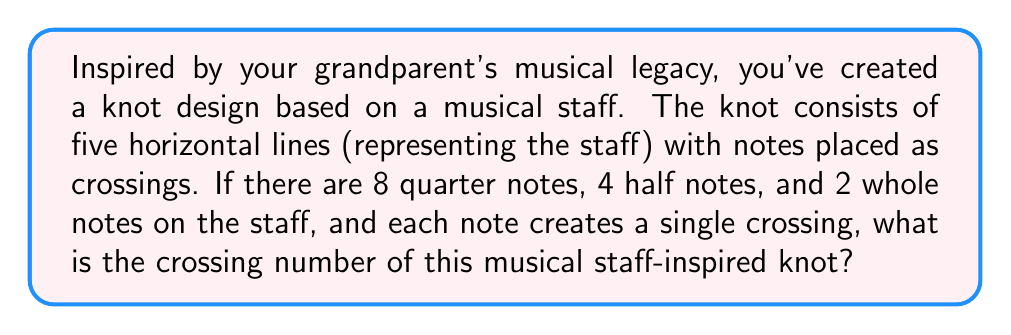What is the answer to this math problem? To calculate the crossing number of this musical staff-inspired knot, we need to follow these steps:

1. Understand the concept of crossing number:
   The crossing number of a knot is the minimum number of crossings that occur in any projection of the knot onto a plane.

2. Count the crossings created by each type of note:
   - Quarter notes: 8 crossings (1 crossing each)
   - Half notes: 4 crossings (1 crossing each)
   - Whole notes: 2 crossings (1 crossing each)

3. Sum up all the crossings:
   Total crossings = Quarter note crossings + Half note crossings + Whole note crossings
   $$\text{Total crossings} = 8 + 4 + 2 = 14$$

4. Consider potential simplifications:
   In this case, since each note creates a single crossing and there are no additional crossings mentioned, the total number of crossings is likely the minimum possible for this knot configuration.

Therefore, the crossing number of this musical staff-inspired knot is 14.
Answer: 14 